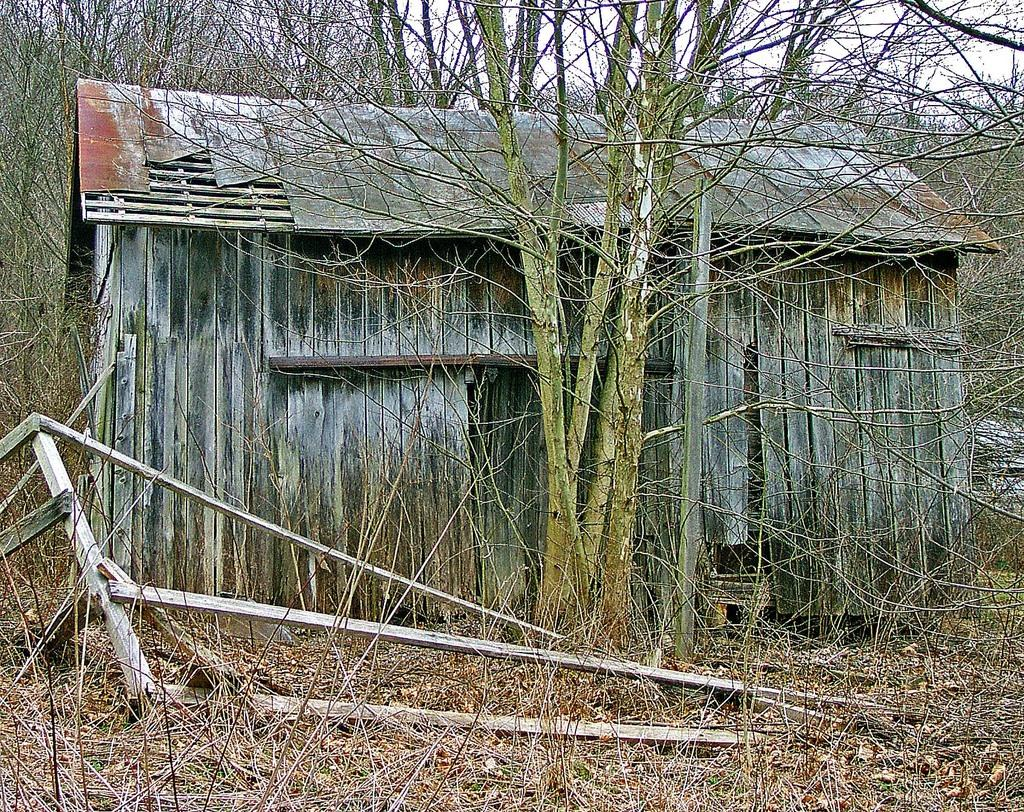What type of vegetation can be seen in the image? There are dried trees in the image. What structure is visible in the background of the image? There is a house in the background of the image. What color is the house in the image? The house is gray in color. What is the color of the sky in the image? The sky is white in color. Can you tell me how many people are involved in the fight in the image? There is no fight present in the image; it features dried trees, a gray house, and a white sky. What type of lumber is being used to construct the house in the image? The image does not provide information about the materials used to construct the house, only that it is gray in color. 